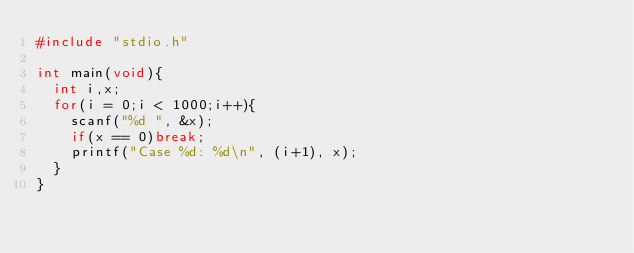<code> <loc_0><loc_0><loc_500><loc_500><_C_>#include "stdio.h"

int main(void){
  int i,x;
  for(i = 0;i < 1000;i++){
    scanf("%d ", &x);
    if(x == 0)break;
    printf("Case %d: %d\n", (i+1), x);
  }
}

</code> 